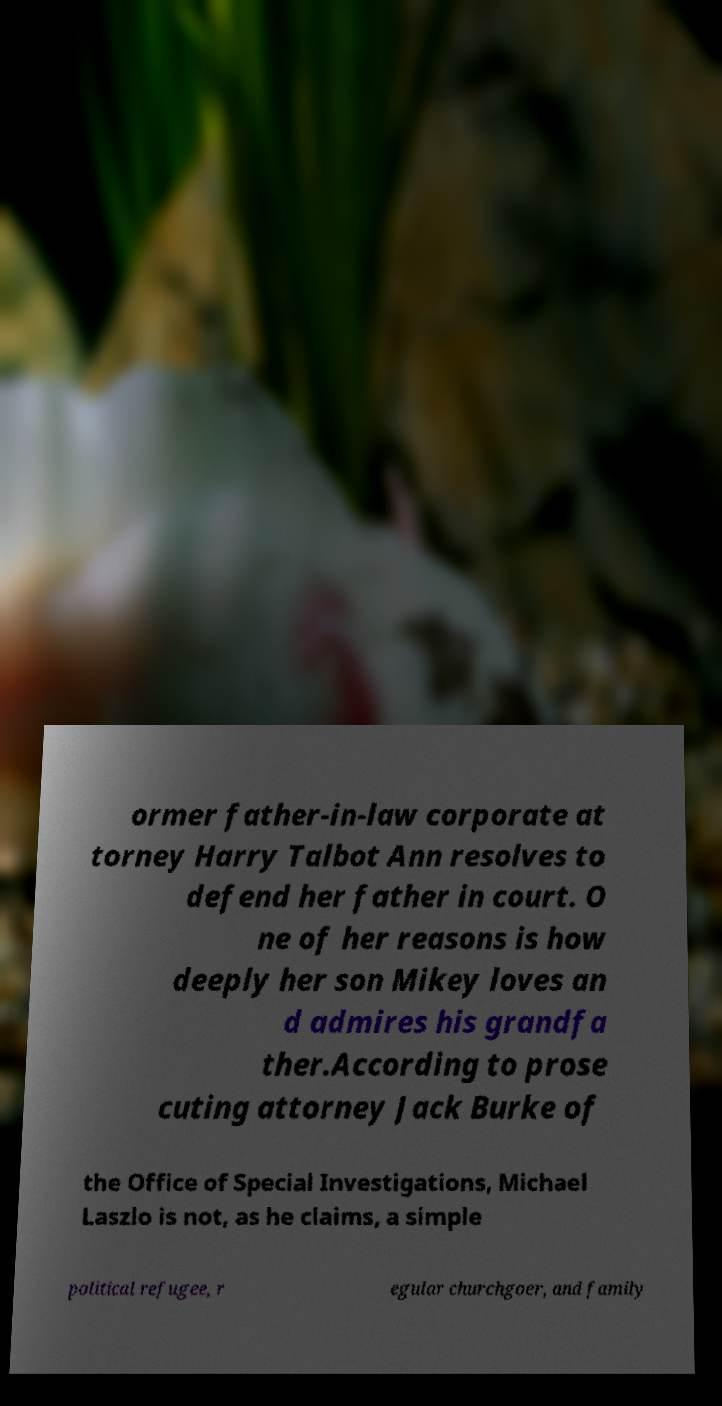I need the written content from this picture converted into text. Can you do that? ormer father-in-law corporate at torney Harry Talbot Ann resolves to defend her father in court. O ne of her reasons is how deeply her son Mikey loves an d admires his grandfa ther.According to prose cuting attorney Jack Burke of the Office of Special Investigations, Michael Laszlo is not, as he claims, a simple political refugee, r egular churchgoer, and family 